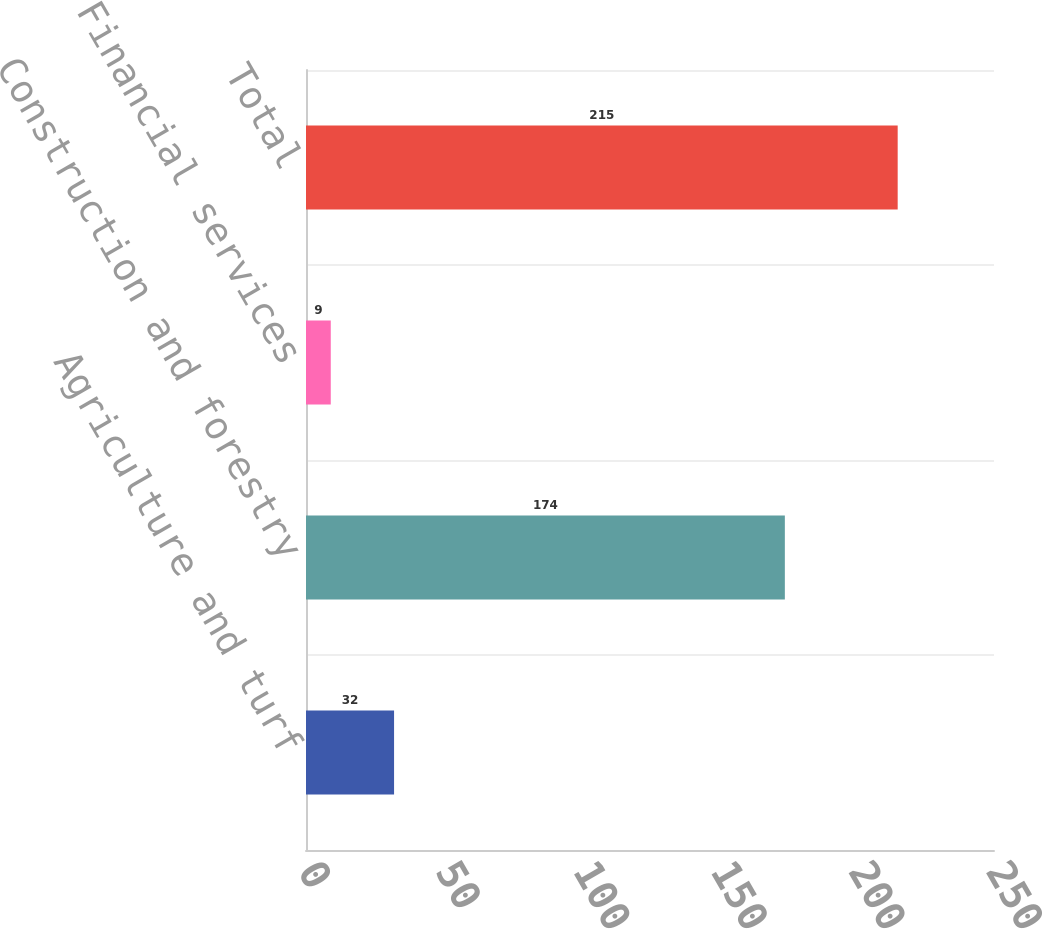Convert chart. <chart><loc_0><loc_0><loc_500><loc_500><bar_chart><fcel>Agriculture and turf<fcel>Construction and forestry<fcel>Financial services<fcel>Total<nl><fcel>32<fcel>174<fcel>9<fcel>215<nl></chart> 